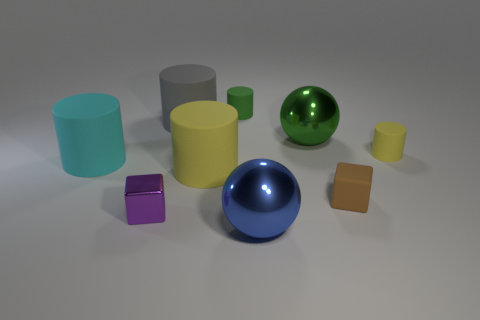The yellow cylinder that is to the left of the metallic thing right of the large sphere in front of the small purple cube is made of what material?
Your answer should be very brief. Rubber. What number of shiny objects are tiny purple things or tiny yellow cylinders?
Your answer should be compact. 1. How many yellow objects are either big things or cylinders?
Your answer should be very brief. 2. There is a sphere that is in front of the purple cube; is its color the same as the shiny cube?
Make the answer very short. No. Are the tiny purple object and the tiny yellow object made of the same material?
Keep it short and to the point. No. Are there an equal number of big green metal things behind the tiny green matte object and brown things in front of the small purple object?
Offer a very short reply. Yes. What is the material of the tiny yellow object that is the same shape as the green rubber thing?
Your response must be concise. Rubber. The yellow rubber object that is in front of the yellow cylinder on the right side of the yellow rubber cylinder that is on the left side of the brown matte thing is what shape?
Give a very brief answer. Cylinder. Are there more small brown rubber cubes left of the large green object than green things?
Give a very brief answer. No. Does the yellow thing on the left side of the small green matte cylinder have the same shape as the large green metal object?
Offer a very short reply. No. 